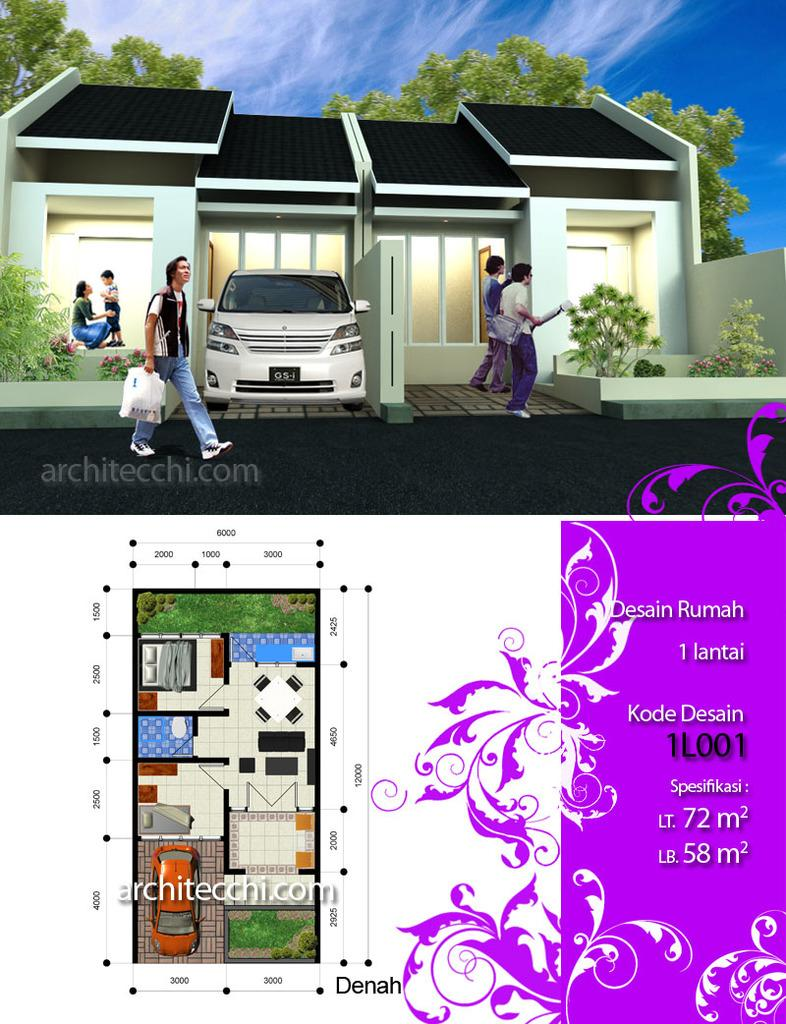What type of building is visible in the image? There is a house in the image. What mode of transportation can be seen in the image? There is a car in the image. What type of vegetation is present in the image? There are plants, flowers, and trees in the image. What additional item can be seen in the image? There is a map in the image. Are there any people visible in the image? Yes, there are people in the image. What is visible in the background of the image? The sky is visible in the background of the image. How many crayons are being used by the women in the image? There are no women or crayons present in the image. What type of chickens can be seen in the image? There are no chickens present in the image. 